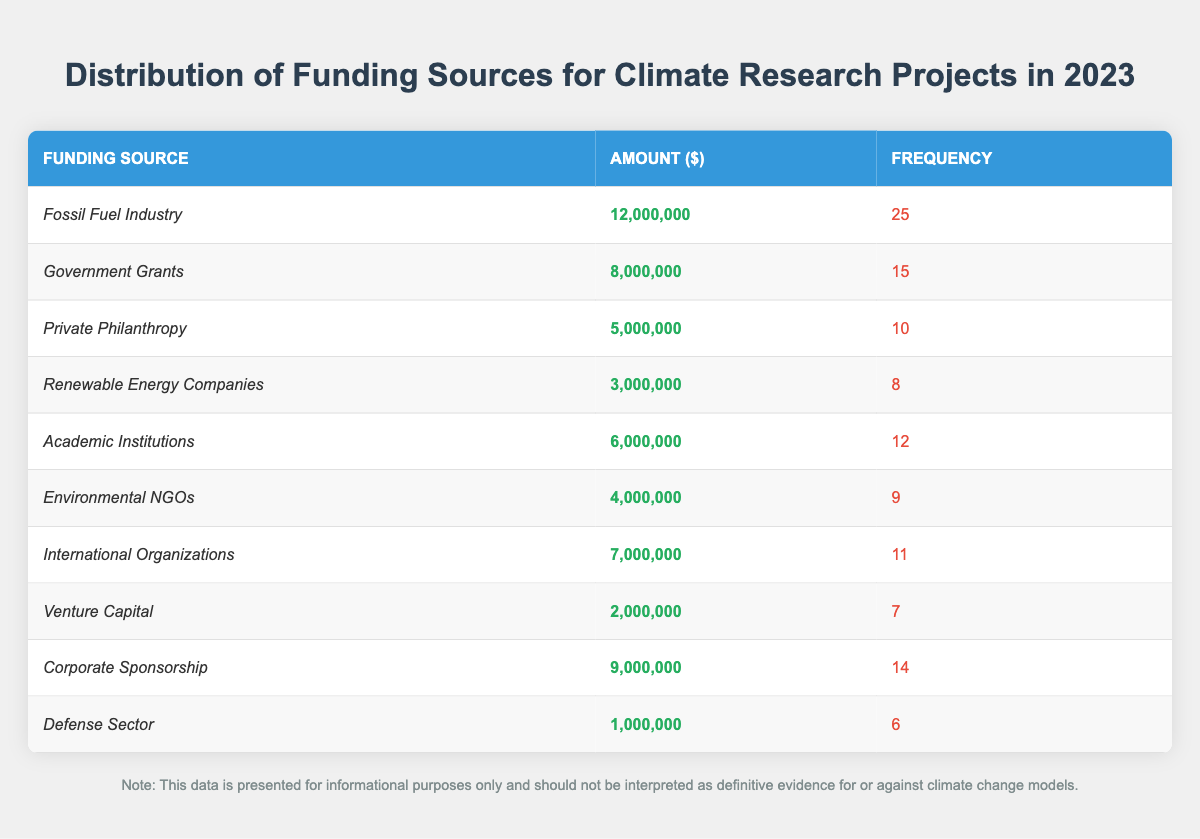What is the funding source with the highest amount? The table shows that the "Fossil Fuel Industry" has the highest funding amount of 12,000,000 dollars compared to other sources.
Answer: Fossil Fuel Industry How many frequency counts are associated with the "Environmental NGOs"? By checking the table, we see that the frequency for "Environmental NGOs" is listed as 9.
Answer: 9 What is the total funding amount for "Government Grants" and "Corporate Sponsorship" combined? From the table, "Government Grants" amount to 8,000,000 and "Corporate Sponsorship" amounts to 9,000,000. Adding these together: 8,000,000 + 9,000,000 = 17,000,000.
Answer: 17,000,000 Is the funding from "Venture Capital" more than the funding from "Defense Sector"? The table shows "Venture Capital" has 2,000,000 while "Defense Sector" has 1,000,000. Since 2,000,000 > 1,000,000, the statement is true.
Answer: Yes What is the average funding amount of all the sources listed in the table? The total amount funded is 12,000,000 + 8,000,000 + 5,000,000 + 3,000,000 + 6,000,000 + 4,000,000 + 7,000,000 + 2,000,000 + 9,000,000 + 1,000,000 = 57,000,000. There are 10 funding sources, so we calculate the average as 57,000,000 / 10 = 5,700,000.
Answer: 5,700,000 How many funding sources have a frequency greater than 10? The table lists "Fossil Fuel Industry" (25), "Government Grants" (15), "Corporate Sponsorship" (14), and "International Organizations" (11) as having frequencies greater than 10, which totals to 4 sources.
Answer: 4 